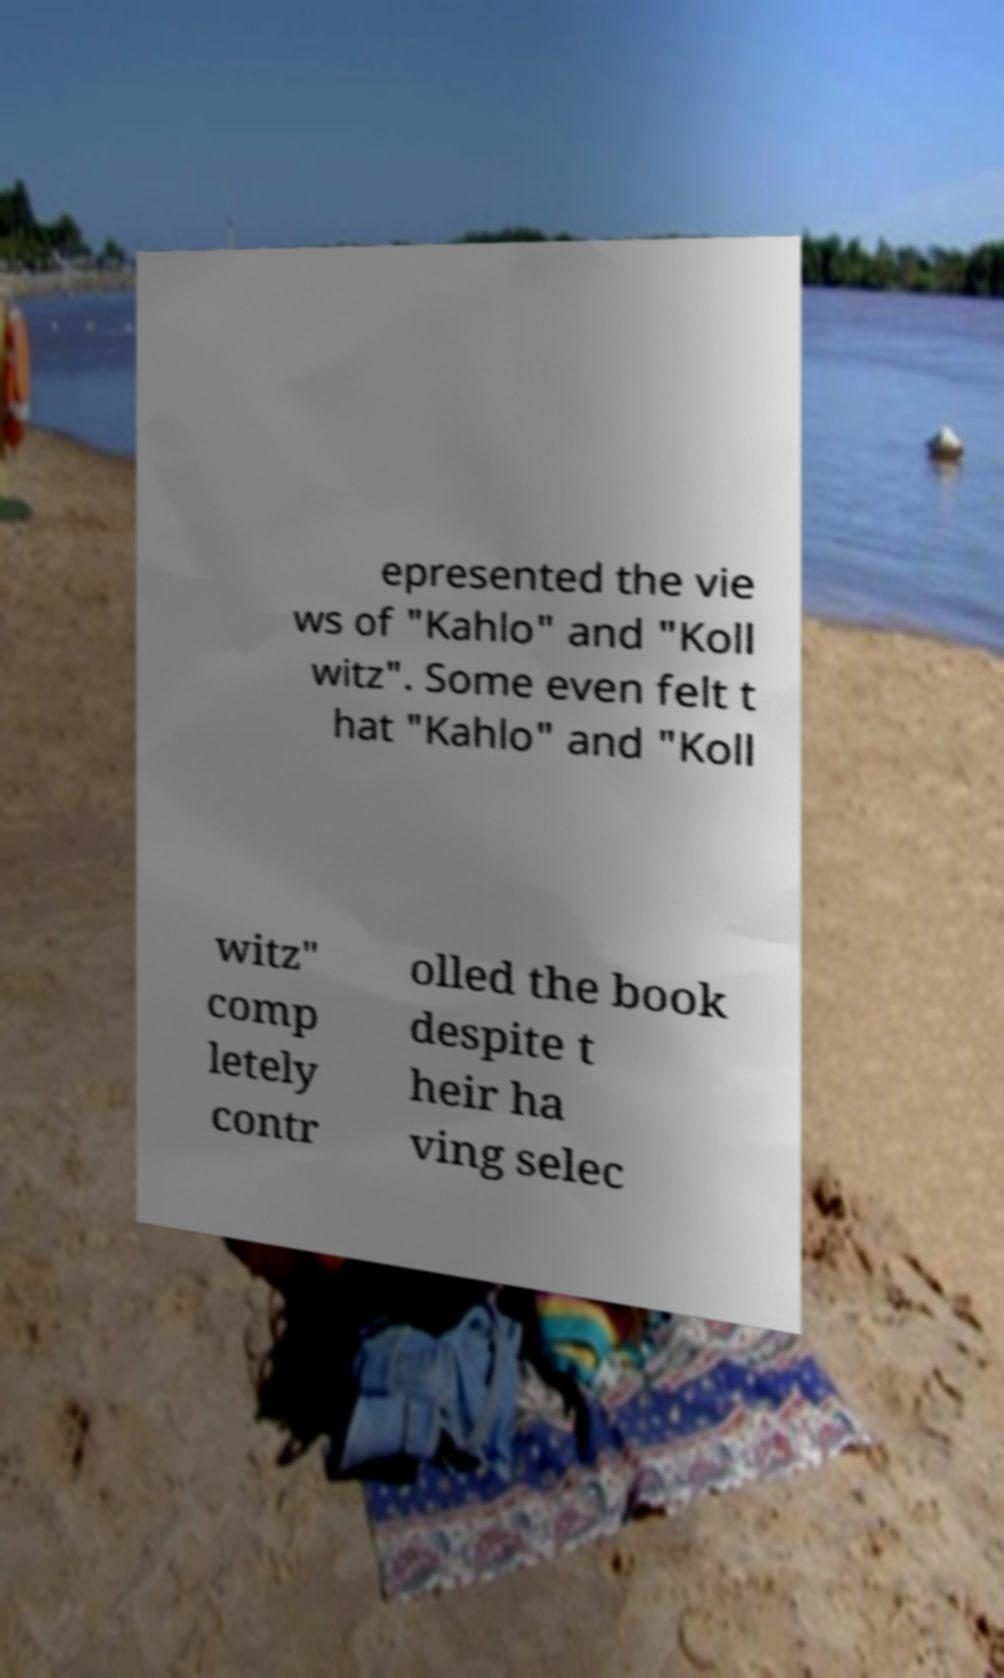Please read and relay the text visible in this image. What does it say? epresented the vie ws of "Kahlo" and "Koll witz". Some even felt t hat "Kahlo" and "Koll witz" comp letely contr olled the book despite t heir ha ving selec 